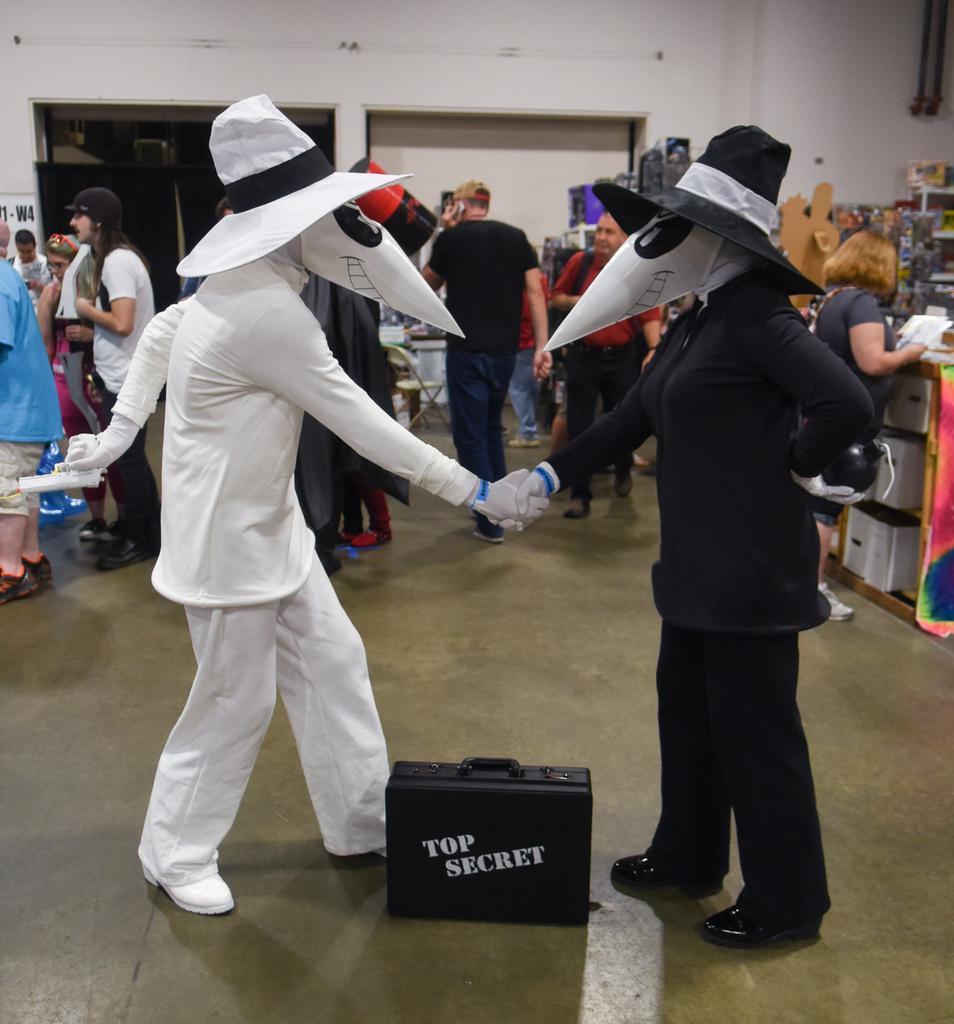Please provide a concise description of this image. In this image I can see the ground and two persons wearing costumes are standing. I can see a black colored suitcase in between them. In the background I can see few persons standing, the white colored wall and few other objects. 